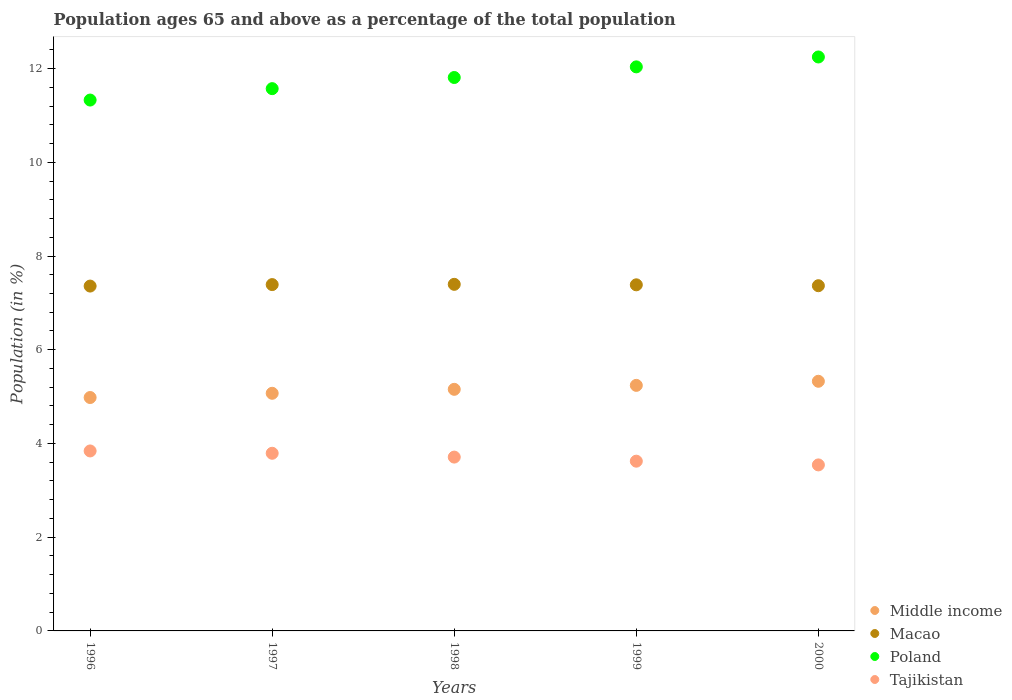How many different coloured dotlines are there?
Give a very brief answer. 4. Is the number of dotlines equal to the number of legend labels?
Provide a succinct answer. Yes. What is the percentage of the population ages 65 and above in Poland in 1997?
Offer a terse response. 11.57. Across all years, what is the maximum percentage of the population ages 65 and above in Middle income?
Provide a succinct answer. 5.33. Across all years, what is the minimum percentage of the population ages 65 and above in Macao?
Offer a terse response. 7.36. In which year was the percentage of the population ages 65 and above in Poland minimum?
Ensure brevity in your answer.  1996. What is the total percentage of the population ages 65 and above in Macao in the graph?
Ensure brevity in your answer.  36.9. What is the difference between the percentage of the population ages 65 and above in Tajikistan in 1999 and that in 2000?
Make the answer very short. 0.08. What is the difference between the percentage of the population ages 65 and above in Macao in 2000 and the percentage of the population ages 65 and above in Poland in 1996?
Keep it short and to the point. -3.96. What is the average percentage of the population ages 65 and above in Tajikistan per year?
Your answer should be compact. 3.7. In the year 1998, what is the difference between the percentage of the population ages 65 and above in Middle income and percentage of the population ages 65 and above in Poland?
Provide a succinct answer. -6.65. In how many years, is the percentage of the population ages 65 and above in Middle income greater than 1.2000000000000002?
Provide a succinct answer. 5. What is the ratio of the percentage of the population ages 65 and above in Poland in 1996 to that in 2000?
Make the answer very short. 0.92. Is the difference between the percentage of the population ages 65 and above in Middle income in 1999 and 2000 greater than the difference between the percentage of the population ages 65 and above in Poland in 1999 and 2000?
Offer a very short reply. Yes. What is the difference between the highest and the second highest percentage of the population ages 65 and above in Middle income?
Provide a succinct answer. 0.09. What is the difference between the highest and the lowest percentage of the population ages 65 and above in Macao?
Give a very brief answer. 0.04. Is the sum of the percentage of the population ages 65 and above in Macao in 1998 and 1999 greater than the maximum percentage of the population ages 65 and above in Middle income across all years?
Provide a succinct answer. Yes. Is it the case that in every year, the sum of the percentage of the population ages 65 and above in Macao and percentage of the population ages 65 and above in Poland  is greater than the sum of percentage of the population ages 65 and above in Middle income and percentage of the population ages 65 and above in Tajikistan?
Your response must be concise. No. Is it the case that in every year, the sum of the percentage of the population ages 65 and above in Tajikistan and percentage of the population ages 65 and above in Poland  is greater than the percentage of the population ages 65 and above in Macao?
Ensure brevity in your answer.  Yes. Does the percentage of the population ages 65 and above in Poland monotonically increase over the years?
Your answer should be very brief. Yes. How many dotlines are there?
Offer a terse response. 4. What is the difference between two consecutive major ticks on the Y-axis?
Ensure brevity in your answer.  2. Does the graph contain any zero values?
Provide a succinct answer. No. Does the graph contain grids?
Give a very brief answer. No. How are the legend labels stacked?
Your response must be concise. Vertical. What is the title of the graph?
Keep it short and to the point. Population ages 65 and above as a percentage of the total population. Does "Kuwait" appear as one of the legend labels in the graph?
Your response must be concise. No. What is the label or title of the Y-axis?
Offer a terse response. Population (in %). What is the Population (in %) of Middle income in 1996?
Give a very brief answer. 4.98. What is the Population (in %) in Macao in 1996?
Keep it short and to the point. 7.36. What is the Population (in %) of Poland in 1996?
Provide a succinct answer. 11.33. What is the Population (in %) of Tajikistan in 1996?
Offer a very short reply. 3.84. What is the Population (in %) of Middle income in 1997?
Make the answer very short. 5.07. What is the Population (in %) in Macao in 1997?
Provide a short and direct response. 7.39. What is the Population (in %) in Poland in 1997?
Provide a succinct answer. 11.57. What is the Population (in %) of Tajikistan in 1997?
Your response must be concise. 3.79. What is the Population (in %) of Middle income in 1998?
Give a very brief answer. 5.16. What is the Population (in %) in Macao in 1998?
Provide a short and direct response. 7.4. What is the Population (in %) of Poland in 1998?
Provide a succinct answer. 11.81. What is the Population (in %) of Tajikistan in 1998?
Provide a short and direct response. 3.71. What is the Population (in %) of Middle income in 1999?
Your response must be concise. 5.24. What is the Population (in %) in Macao in 1999?
Ensure brevity in your answer.  7.39. What is the Population (in %) of Poland in 1999?
Keep it short and to the point. 12.04. What is the Population (in %) of Tajikistan in 1999?
Keep it short and to the point. 3.62. What is the Population (in %) of Middle income in 2000?
Offer a very short reply. 5.33. What is the Population (in %) of Macao in 2000?
Your answer should be compact. 7.37. What is the Population (in %) in Poland in 2000?
Give a very brief answer. 12.25. What is the Population (in %) in Tajikistan in 2000?
Offer a terse response. 3.54. Across all years, what is the maximum Population (in %) of Middle income?
Offer a terse response. 5.33. Across all years, what is the maximum Population (in %) of Macao?
Your answer should be very brief. 7.4. Across all years, what is the maximum Population (in %) in Poland?
Ensure brevity in your answer.  12.25. Across all years, what is the maximum Population (in %) of Tajikistan?
Your answer should be very brief. 3.84. Across all years, what is the minimum Population (in %) of Middle income?
Provide a succinct answer. 4.98. Across all years, what is the minimum Population (in %) in Macao?
Give a very brief answer. 7.36. Across all years, what is the minimum Population (in %) in Poland?
Provide a succinct answer. 11.33. Across all years, what is the minimum Population (in %) in Tajikistan?
Your answer should be compact. 3.54. What is the total Population (in %) in Middle income in the graph?
Your answer should be very brief. 25.77. What is the total Population (in %) in Macao in the graph?
Offer a terse response. 36.9. What is the total Population (in %) of Poland in the graph?
Your response must be concise. 58.99. What is the total Population (in %) in Tajikistan in the graph?
Keep it short and to the point. 18.5. What is the difference between the Population (in %) in Middle income in 1996 and that in 1997?
Ensure brevity in your answer.  -0.09. What is the difference between the Population (in %) in Macao in 1996 and that in 1997?
Your response must be concise. -0.03. What is the difference between the Population (in %) of Poland in 1996 and that in 1997?
Keep it short and to the point. -0.24. What is the difference between the Population (in %) in Tajikistan in 1996 and that in 1997?
Provide a short and direct response. 0.05. What is the difference between the Population (in %) in Middle income in 1996 and that in 1998?
Make the answer very short. -0.17. What is the difference between the Population (in %) of Macao in 1996 and that in 1998?
Your response must be concise. -0.04. What is the difference between the Population (in %) of Poland in 1996 and that in 1998?
Your answer should be compact. -0.48. What is the difference between the Population (in %) in Tajikistan in 1996 and that in 1998?
Make the answer very short. 0.13. What is the difference between the Population (in %) of Middle income in 1996 and that in 1999?
Your answer should be compact. -0.26. What is the difference between the Population (in %) in Macao in 1996 and that in 1999?
Give a very brief answer. -0.03. What is the difference between the Population (in %) in Poland in 1996 and that in 1999?
Provide a short and direct response. -0.71. What is the difference between the Population (in %) of Tajikistan in 1996 and that in 1999?
Ensure brevity in your answer.  0.22. What is the difference between the Population (in %) in Middle income in 1996 and that in 2000?
Your answer should be compact. -0.35. What is the difference between the Population (in %) of Macao in 1996 and that in 2000?
Your answer should be very brief. -0.01. What is the difference between the Population (in %) in Poland in 1996 and that in 2000?
Offer a terse response. -0.92. What is the difference between the Population (in %) in Tajikistan in 1996 and that in 2000?
Give a very brief answer. 0.3. What is the difference between the Population (in %) of Middle income in 1997 and that in 1998?
Your response must be concise. -0.08. What is the difference between the Population (in %) in Macao in 1997 and that in 1998?
Provide a short and direct response. -0.01. What is the difference between the Population (in %) in Poland in 1997 and that in 1998?
Make the answer very short. -0.24. What is the difference between the Population (in %) of Tajikistan in 1997 and that in 1998?
Provide a succinct answer. 0.08. What is the difference between the Population (in %) in Middle income in 1997 and that in 1999?
Make the answer very short. -0.17. What is the difference between the Population (in %) of Macao in 1997 and that in 1999?
Your answer should be compact. 0. What is the difference between the Population (in %) of Poland in 1997 and that in 1999?
Keep it short and to the point. -0.46. What is the difference between the Population (in %) in Tajikistan in 1997 and that in 1999?
Offer a terse response. 0.17. What is the difference between the Population (in %) of Middle income in 1997 and that in 2000?
Provide a short and direct response. -0.26. What is the difference between the Population (in %) of Macao in 1997 and that in 2000?
Give a very brief answer. 0.02. What is the difference between the Population (in %) in Poland in 1997 and that in 2000?
Ensure brevity in your answer.  -0.68. What is the difference between the Population (in %) in Tajikistan in 1997 and that in 2000?
Provide a succinct answer. 0.25. What is the difference between the Population (in %) of Middle income in 1998 and that in 1999?
Your response must be concise. -0.08. What is the difference between the Population (in %) in Macao in 1998 and that in 1999?
Offer a terse response. 0.01. What is the difference between the Population (in %) of Poland in 1998 and that in 1999?
Offer a very short reply. -0.23. What is the difference between the Population (in %) in Tajikistan in 1998 and that in 1999?
Offer a very short reply. 0.09. What is the difference between the Population (in %) in Middle income in 1998 and that in 2000?
Your answer should be very brief. -0.17. What is the difference between the Population (in %) in Macao in 1998 and that in 2000?
Keep it short and to the point. 0.03. What is the difference between the Population (in %) in Poland in 1998 and that in 2000?
Offer a terse response. -0.44. What is the difference between the Population (in %) of Tajikistan in 1998 and that in 2000?
Make the answer very short. 0.17. What is the difference between the Population (in %) in Middle income in 1999 and that in 2000?
Ensure brevity in your answer.  -0.09. What is the difference between the Population (in %) in Macao in 1999 and that in 2000?
Your answer should be very brief. 0.02. What is the difference between the Population (in %) in Poland in 1999 and that in 2000?
Offer a terse response. -0.21. What is the difference between the Population (in %) of Tajikistan in 1999 and that in 2000?
Your response must be concise. 0.08. What is the difference between the Population (in %) of Middle income in 1996 and the Population (in %) of Macao in 1997?
Keep it short and to the point. -2.41. What is the difference between the Population (in %) in Middle income in 1996 and the Population (in %) in Poland in 1997?
Your answer should be very brief. -6.59. What is the difference between the Population (in %) in Middle income in 1996 and the Population (in %) in Tajikistan in 1997?
Make the answer very short. 1.19. What is the difference between the Population (in %) in Macao in 1996 and the Population (in %) in Poland in 1997?
Give a very brief answer. -4.21. What is the difference between the Population (in %) of Macao in 1996 and the Population (in %) of Tajikistan in 1997?
Your response must be concise. 3.57. What is the difference between the Population (in %) of Poland in 1996 and the Population (in %) of Tajikistan in 1997?
Keep it short and to the point. 7.54. What is the difference between the Population (in %) in Middle income in 1996 and the Population (in %) in Macao in 1998?
Keep it short and to the point. -2.42. What is the difference between the Population (in %) of Middle income in 1996 and the Population (in %) of Poland in 1998?
Provide a short and direct response. -6.83. What is the difference between the Population (in %) in Middle income in 1996 and the Population (in %) in Tajikistan in 1998?
Provide a succinct answer. 1.27. What is the difference between the Population (in %) of Macao in 1996 and the Population (in %) of Poland in 1998?
Offer a very short reply. -4.45. What is the difference between the Population (in %) in Macao in 1996 and the Population (in %) in Tajikistan in 1998?
Your response must be concise. 3.65. What is the difference between the Population (in %) of Poland in 1996 and the Population (in %) of Tajikistan in 1998?
Provide a short and direct response. 7.62. What is the difference between the Population (in %) of Middle income in 1996 and the Population (in %) of Macao in 1999?
Make the answer very short. -2.4. What is the difference between the Population (in %) of Middle income in 1996 and the Population (in %) of Poland in 1999?
Provide a succinct answer. -7.06. What is the difference between the Population (in %) of Middle income in 1996 and the Population (in %) of Tajikistan in 1999?
Offer a terse response. 1.36. What is the difference between the Population (in %) in Macao in 1996 and the Population (in %) in Poland in 1999?
Your response must be concise. -4.68. What is the difference between the Population (in %) of Macao in 1996 and the Population (in %) of Tajikistan in 1999?
Provide a succinct answer. 3.74. What is the difference between the Population (in %) of Poland in 1996 and the Population (in %) of Tajikistan in 1999?
Offer a terse response. 7.71. What is the difference between the Population (in %) of Middle income in 1996 and the Population (in %) of Macao in 2000?
Provide a short and direct response. -2.39. What is the difference between the Population (in %) of Middle income in 1996 and the Population (in %) of Poland in 2000?
Offer a terse response. -7.27. What is the difference between the Population (in %) in Middle income in 1996 and the Population (in %) in Tajikistan in 2000?
Provide a succinct answer. 1.44. What is the difference between the Population (in %) of Macao in 1996 and the Population (in %) of Poland in 2000?
Give a very brief answer. -4.89. What is the difference between the Population (in %) of Macao in 1996 and the Population (in %) of Tajikistan in 2000?
Your response must be concise. 3.82. What is the difference between the Population (in %) of Poland in 1996 and the Population (in %) of Tajikistan in 2000?
Provide a short and direct response. 7.79. What is the difference between the Population (in %) of Middle income in 1997 and the Population (in %) of Macao in 1998?
Your answer should be compact. -2.33. What is the difference between the Population (in %) of Middle income in 1997 and the Population (in %) of Poland in 1998?
Provide a succinct answer. -6.74. What is the difference between the Population (in %) in Middle income in 1997 and the Population (in %) in Tajikistan in 1998?
Provide a succinct answer. 1.36. What is the difference between the Population (in %) in Macao in 1997 and the Population (in %) in Poland in 1998?
Ensure brevity in your answer.  -4.42. What is the difference between the Population (in %) of Macao in 1997 and the Population (in %) of Tajikistan in 1998?
Offer a very short reply. 3.68. What is the difference between the Population (in %) in Poland in 1997 and the Population (in %) in Tajikistan in 1998?
Offer a terse response. 7.86. What is the difference between the Population (in %) in Middle income in 1997 and the Population (in %) in Macao in 1999?
Keep it short and to the point. -2.31. What is the difference between the Population (in %) in Middle income in 1997 and the Population (in %) in Poland in 1999?
Give a very brief answer. -6.97. What is the difference between the Population (in %) of Middle income in 1997 and the Population (in %) of Tajikistan in 1999?
Ensure brevity in your answer.  1.45. What is the difference between the Population (in %) in Macao in 1997 and the Population (in %) in Poland in 1999?
Provide a succinct answer. -4.65. What is the difference between the Population (in %) in Macao in 1997 and the Population (in %) in Tajikistan in 1999?
Keep it short and to the point. 3.77. What is the difference between the Population (in %) in Poland in 1997 and the Population (in %) in Tajikistan in 1999?
Offer a very short reply. 7.95. What is the difference between the Population (in %) in Middle income in 1997 and the Population (in %) in Macao in 2000?
Give a very brief answer. -2.3. What is the difference between the Population (in %) of Middle income in 1997 and the Population (in %) of Poland in 2000?
Your answer should be very brief. -7.18. What is the difference between the Population (in %) in Middle income in 1997 and the Population (in %) in Tajikistan in 2000?
Provide a succinct answer. 1.53. What is the difference between the Population (in %) in Macao in 1997 and the Population (in %) in Poland in 2000?
Ensure brevity in your answer.  -4.86. What is the difference between the Population (in %) of Macao in 1997 and the Population (in %) of Tajikistan in 2000?
Ensure brevity in your answer.  3.85. What is the difference between the Population (in %) of Poland in 1997 and the Population (in %) of Tajikistan in 2000?
Provide a short and direct response. 8.03. What is the difference between the Population (in %) in Middle income in 1998 and the Population (in %) in Macao in 1999?
Your answer should be compact. -2.23. What is the difference between the Population (in %) of Middle income in 1998 and the Population (in %) of Poland in 1999?
Make the answer very short. -6.88. What is the difference between the Population (in %) in Middle income in 1998 and the Population (in %) in Tajikistan in 1999?
Offer a terse response. 1.53. What is the difference between the Population (in %) of Macao in 1998 and the Population (in %) of Poland in 1999?
Make the answer very short. -4.64. What is the difference between the Population (in %) of Macao in 1998 and the Population (in %) of Tajikistan in 1999?
Your response must be concise. 3.77. What is the difference between the Population (in %) of Poland in 1998 and the Population (in %) of Tajikistan in 1999?
Make the answer very short. 8.19. What is the difference between the Population (in %) in Middle income in 1998 and the Population (in %) in Macao in 2000?
Offer a terse response. -2.21. What is the difference between the Population (in %) of Middle income in 1998 and the Population (in %) of Poland in 2000?
Offer a very short reply. -7.09. What is the difference between the Population (in %) of Middle income in 1998 and the Population (in %) of Tajikistan in 2000?
Your answer should be compact. 1.61. What is the difference between the Population (in %) in Macao in 1998 and the Population (in %) in Poland in 2000?
Offer a terse response. -4.85. What is the difference between the Population (in %) in Macao in 1998 and the Population (in %) in Tajikistan in 2000?
Provide a short and direct response. 3.85. What is the difference between the Population (in %) of Poland in 1998 and the Population (in %) of Tajikistan in 2000?
Offer a very short reply. 8.27. What is the difference between the Population (in %) in Middle income in 1999 and the Population (in %) in Macao in 2000?
Make the answer very short. -2.13. What is the difference between the Population (in %) of Middle income in 1999 and the Population (in %) of Poland in 2000?
Provide a short and direct response. -7.01. What is the difference between the Population (in %) in Middle income in 1999 and the Population (in %) in Tajikistan in 2000?
Offer a very short reply. 1.7. What is the difference between the Population (in %) of Macao in 1999 and the Population (in %) of Poland in 2000?
Ensure brevity in your answer.  -4.86. What is the difference between the Population (in %) of Macao in 1999 and the Population (in %) of Tajikistan in 2000?
Your answer should be very brief. 3.84. What is the difference between the Population (in %) of Poland in 1999 and the Population (in %) of Tajikistan in 2000?
Your response must be concise. 8.49. What is the average Population (in %) of Middle income per year?
Your answer should be very brief. 5.15. What is the average Population (in %) in Macao per year?
Ensure brevity in your answer.  7.38. What is the average Population (in %) of Poland per year?
Keep it short and to the point. 11.8. What is the average Population (in %) in Tajikistan per year?
Provide a short and direct response. 3.7. In the year 1996, what is the difference between the Population (in %) of Middle income and Population (in %) of Macao?
Ensure brevity in your answer.  -2.38. In the year 1996, what is the difference between the Population (in %) in Middle income and Population (in %) in Poland?
Your response must be concise. -6.35. In the year 1996, what is the difference between the Population (in %) in Middle income and Population (in %) in Tajikistan?
Keep it short and to the point. 1.14. In the year 1996, what is the difference between the Population (in %) of Macao and Population (in %) of Poland?
Keep it short and to the point. -3.97. In the year 1996, what is the difference between the Population (in %) in Macao and Population (in %) in Tajikistan?
Provide a succinct answer. 3.52. In the year 1996, what is the difference between the Population (in %) in Poland and Population (in %) in Tajikistan?
Provide a short and direct response. 7.49. In the year 1997, what is the difference between the Population (in %) of Middle income and Population (in %) of Macao?
Provide a short and direct response. -2.32. In the year 1997, what is the difference between the Population (in %) of Middle income and Population (in %) of Poland?
Give a very brief answer. -6.5. In the year 1997, what is the difference between the Population (in %) in Middle income and Population (in %) in Tajikistan?
Offer a terse response. 1.28. In the year 1997, what is the difference between the Population (in %) in Macao and Population (in %) in Poland?
Your response must be concise. -4.18. In the year 1997, what is the difference between the Population (in %) in Macao and Population (in %) in Tajikistan?
Keep it short and to the point. 3.6. In the year 1997, what is the difference between the Population (in %) in Poland and Population (in %) in Tajikistan?
Ensure brevity in your answer.  7.78. In the year 1998, what is the difference between the Population (in %) in Middle income and Population (in %) in Macao?
Keep it short and to the point. -2.24. In the year 1998, what is the difference between the Population (in %) in Middle income and Population (in %) in Poland?
Give a very brief answer. -6.65. In the year 1998, what is the difference between the Population (in %) in Middle income and Population (in %) in Tajikistan?
Your answer should be very brief. 1.45. In the year 1998, what is the difference between the Population (in %) of Macao and Population (in %) of Poland?
Provide a succinct answer. -4.41. In the year 1998, what is the difference between the Population (in %) of Macao and Population (in %) of Tajikistan?
Provide a short and direct response. 3.69. In the year 1998, what is the difference between the Population (in %) of Poland and Population (in %) of Tajikistan?
Make the answer very short. 8.1. In the year 1999, what is the difference between the Population (in %) of Middle income and Population (in %) of Macao?
Give a very brief answer. -2.15. In the year 1999, what is the difference between the Population (in %) of Middle income and Population (in %) of Poland?
Provide a succinct answer. -6.8. In the year 1999, what is the difference between the Population (in %) in Middle income and Population (in %) in Tajikistan?
Your response must be concise. 1.62. In the year 1999, what is the difference between the Population (in %) of Macao and Population (in %) of Poland?
Ensure brevity in your answer.  -4.65. In the year 1999, what is the difference between the Population (in %) of Macao and Population (in %) of Tajikistan?
Provide a short and direct response. 3.76. In the year 1999, what is the difference between the Population (in %) in Poland and Population (in %) in Tajikistan?
Your answer should be compact. 8.41. In the year 2000, what is the difference between the Population (in %) of Middle income and Population (in %) of Macao?
Make the answer very short. -2.04. In the year 2000, what is the difference between the Population (in %) of Middle income and Population (in %) of Poland?
Provide a short and direct response. -6.92. In the year 2000, what is the difference between the Population (in %) of Middle income and Population (in %) of Tajikistan?
Provide a succinct answer. 1.78. In the year 2000, what is the difference between the Population (in %) in Macao and Population (in %) in Poland?
Your answer should be compact. -4.88. In the year 2000, what is the difference between the Population (in %) in Macao and Population (in %) in Tajikistan?
Your answer should be compact. 3.82. In the year 2000, what is the difference between the Population (in %) of Poland and Population (in %) of Tajikistan?
Make the answer very short. 8.7. What is the ratio of the Population (in %) of Middle income in 1996 to that in 1997?
Make the answer very short. 0.98. What is the ratio of the Population (in %) in Tajikistan in 1996 to that in 1997?
Make the answer very short. 1.01. What is the ratio of the Population (in %) of Middle income in 1996 to that in 1998?
Provide a succinct answer. 0.97. What is the ratio of the Population (in %) in Poland in 1996 to that in 1998?
Your answer should be compact. 0.96. What is the ratio of the Population (in %) in Tajikistan in 1996 to that in 1998?
Make the answer very short. 1.04. What is the ratio of the Population (in %) of Middle income in 1996 to that in 1999?
Give a very brief answer. 0.95. What is the ratio of the Population (in %) in Macao in 1996 to that in 1999?
Offer a very short reply. 1. What is the ratio of the Population (in %) of Poland in 1996 to that in 1999?
Ensure brevity in your answer.  0.94. What is the ratio of the Population (in %) of Tajikistan in 1996 to that in 1999?
Provide a short and direct response. 1.06. What is the ratio of the Population (in %) in Middle income in 1996 to that in 2000?
Offer a terse response. 0.93. What is the ratio of the Population (in %) in Poland in 1996 to that in 2000?
Your answer should be very brief. 0.92. What is the ratio of the Population (in %) of Tajikistan in 1996 to that in 2000?
Make the answer very short. 1.08. What is the ratio of the Population (in %) in Middle income in 1997 to that in 1998?
Your answer should be very brief. 0.98. What is the ratio of the Population (in %) of Poland in 1997 to that in 1998?
Provide a succinct answer. 0.98. What is the ratio of the Population (in %) in Middle income in 1997 to that in 1999?
Offer a terse response. 0.97. What is the ratio of the Population (in %) of Poland in 1997 to that in 1999?
Give a very brief answer. 0.96. What is the ratio of the Population (in %) in Tajikistan in 1997 to that in 1999?
Offer a terse response. 1.05. What is the ratio of the Population (in %) in Middle income in 1997 to that in 2000?
Give a very brief answer. 0.95. What is the ratio of the Population (in %) in Poland in 1997 to that in 2000?
Keep it short and to the point. 0.94. What is the ratio of the Population (in %) in Tajikistan in 1997 to that in 2000?
Give a very brief answer. 1.07. What is the ratio of the Population (in %) of Middle income in 1998 to that in 1999?
Provide a succinct answer. 0.98. What is the ratio of the Population (in %) in Poland in 1998 to that in 1999?
Keep it short and to the point. 0.98. What is the ratio of the Population (in %) in Tajikistan in 1998 to that in 1999?
Your answer should be compact. 1.02. What is the ratio of the Population (in %) in Macao in 1998 to that in 2000?
Your response must be concise. 1. What is the ratio of the Population (in %) in Poland in 1998 to that in 2000?
Ensure brevity in your answer.  0.96. What is the ratio of the Population (in %) in Tajikistan in 1998 to that in 2000?
Offer a terse response. 1.05. What is the ratio of the Population (in %) in Middle income in 1999 to that in 2000?
Keep it short and to the point. 0.98. What is the ratio of the Population (in %) of Macao in 1999 to that in 2000?
Offer a terse response. 1. What is the ratio of the Population (in %) in Poland in 1999 to that in 2000?
Your answer should be compact. 0.98. What is the ratio of the Population (in %) in Tajikistan in 1999 to that in 2000?
Offer a terse response. 1.02. What is the difference between the highest and the second highest Population (in %) of Middle income?
Keep it short and to the point. 0.09. What is the difference between the highest and the second highest Population (in %) of Macao?
Provide a succinct answer. 0.01. What is the difference between the highest and the second highest Population (in %) in Poland?
Provide a short and direct response. 0.21. What is the difference between the highest and the second highest Population (in %) of Tajikistan?
Offer a very short reply. 0.05. What is the difference between the highest and the lowest Population (in %) of Middle income?
Your response must be concise. 0.35. What is the difference between the highest and the lowest Population (in %) in Macao?
Make the answer very short. 0.04. What is the difference between the highest and the lowest Population (in %) in Poland?
Give a very brief answer. 0.92. What is the difference between the highest and the lowest Population (in %) in Tajikistan?
Keep it short and to the point. 0.3. 